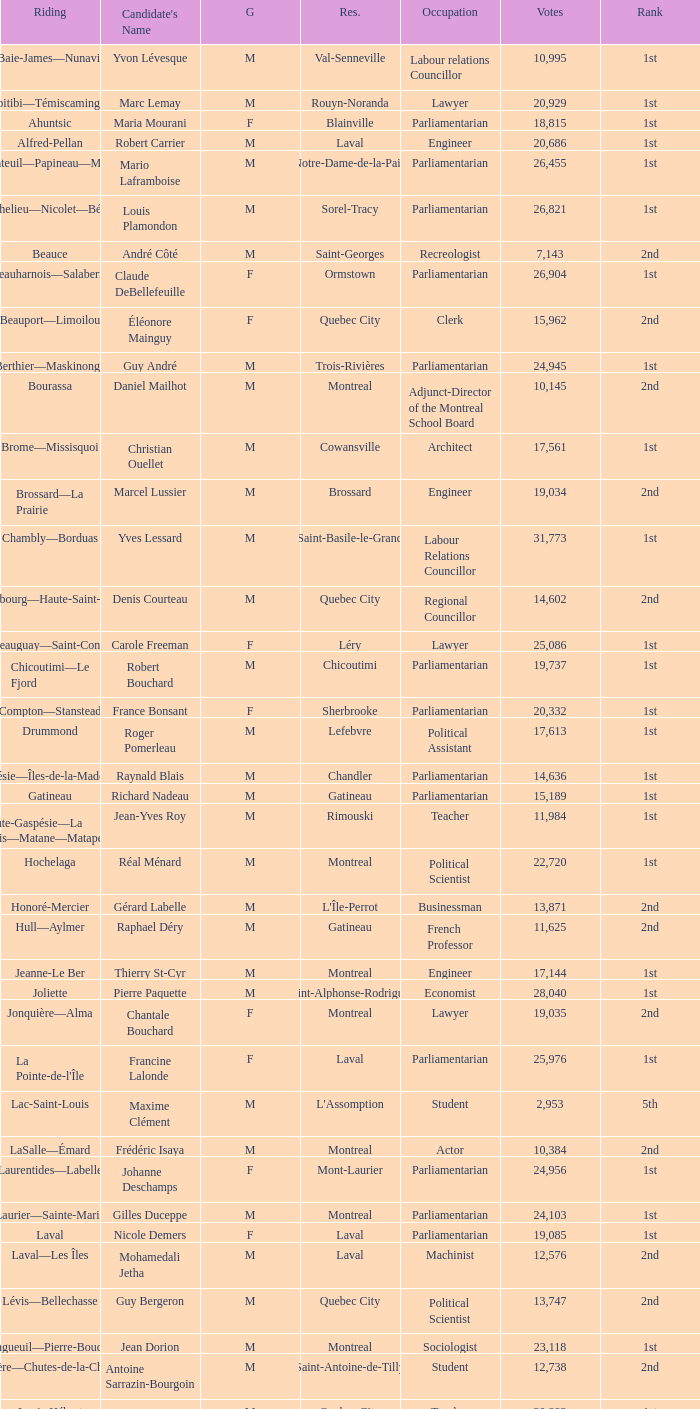What gender is Luc Desnoyers? M. 